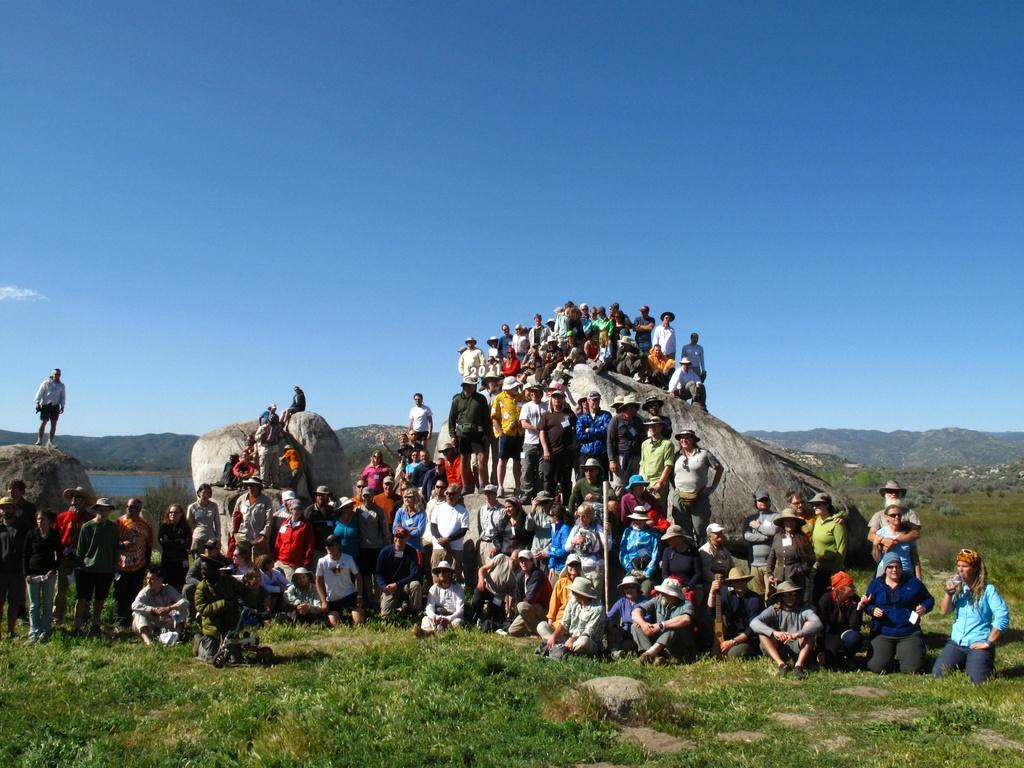How many people are in the image? There is a group of people in the image, but the exact number is not specified. What are the people in the image doing? Some people are sitting, while others are standing. What can be seen in the background of the image? The sky, water, grass, and rocks are visible in the background of the image. Are there any other elements in the background of the image? Yes, there are other unspecified elements in the background of the image. What type of insect is crawling on the servant's shoulder in the image? There is no servant or insect present in the image. 